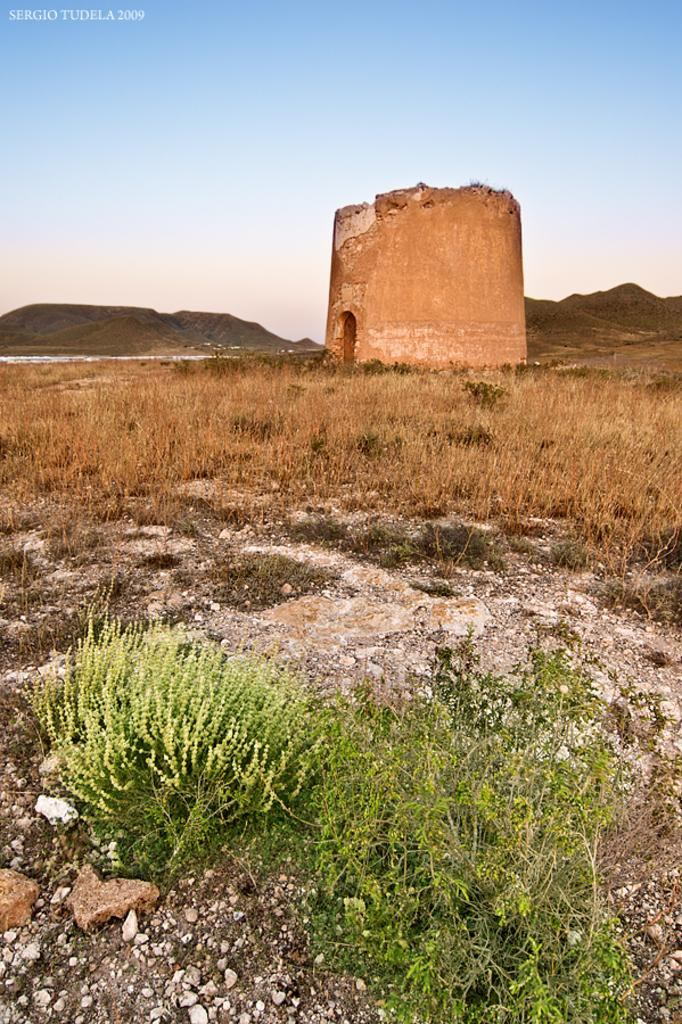What type of vegetation can be seen in the image? There are plants and dried grass in the image. What can be seen in the background of the image? There is a wall, hills, and the sky visible in the background of the image. What might be used to indicate ownership or authorship of the image? There is a watermark in the top left corner of the image. What type of produce is being harvested in the image? There is no produce being harvested in the image; it features plants and dried grass in a landscape setting. What company is responsible for the image? The image does not have any company branding or identification, so it is not possible to determine which company might be responsible for it. 